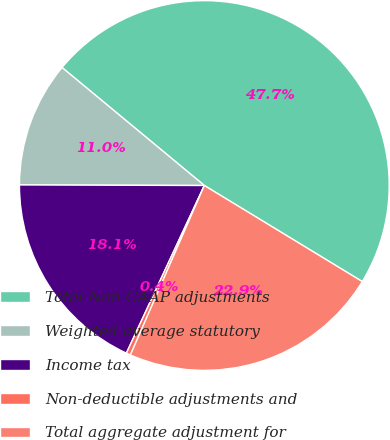<chart> <loc_0><loc_0><loc_500><loc_500><pie_chart><fcel>Total Non-GAAP adjustments<fcel>Weighted-average statutory<fcel>Income tax<fcel>Non-deductible adjustments and<fcel>Total aggregate adjustment for<nl><fcel>47.68%<fcel>10.97%<fcel>18.12%<fcel>0.38%<fcel>22.85%<nl></chart> 